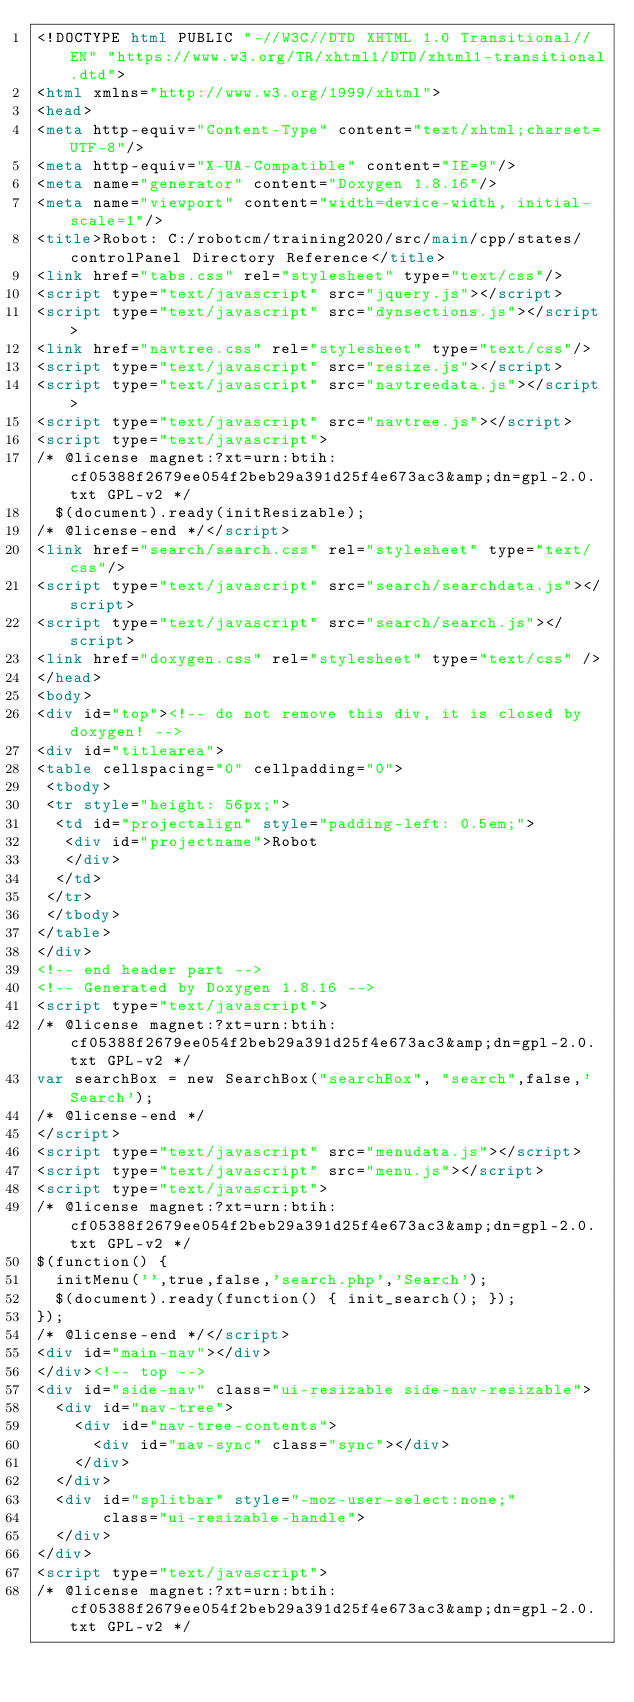Convert code to text. <code><loc_0><loc_0><loc_500><loc_500><_HTML_><!DOCTYPE html PUBLIC "-//W3C//DTD XHTML 1.0 Transitional//EN" "https://www.w3.org/TR/xhtml1/DTD/xhtml1-transitional.dtd">
<html xmlns="http://www.w3.org/1999/xhtml">
<head>
<meta http-equiv="Content-Type" content="text/xhtml;charset=UTF-8"/>
<meta http-equiv="X-UA-Compatible" content="IE=9"/>
<meta name="generator" content="Doxygen 1.8.16"/>
<meta name="viewport" content="width=device-width, initial-scale=1"/>
<title>Robot: C:/robotcm/training2020/src/main/cpp/states/controlPanel Directory Reference</title>
<link href="tabs.css" rel="stylesheet" type="text/css"/>
<script type="text/javascript" src="jquery.js"></script>
<script type="text/javascript" src="dynsections.js"></script>
<link href="navtree.css" rel="stylesheet" type="text/css"/>
<script type="text/javascript" src="resize.js"></script>
<script type="text/javascript" src="navtreedata.js"></script>
<script type="text/javascript" src="navtree.js"></script>
<script type="text/javascript">
/* @license magnet:?xt=urn:btih:cf05388f2679ee054f2beb29a391d25f4e673ac3&amp;dn=gpl-2.0.txt GPL-v2 */
  $(document).ready(initResizable);
/* @license-end */</script>
<link href="search/search.css" rel="stylesheet" type="text/css"/>
<script type="text/javascript" src="search/searchdata.js"></script>
<script type="text/javascript" src="search/search.js"></script>
<link href="doxygen.css" rel="stylesheet" type="text/css" />
</head>
<body>
<div id="top"><!-- do not remove this div, it is closed by doxygen! -->
<div id="titlearea">
<table cellspacing="0" cellpadding="0">
 <tbody>
 <tr style="height: 56px;">
  <td id="projectalign" style="padding-left: 0.5em;">
   <div id="projectname">Robot
   </div>
  </td>
 </tr>
 </tbody>
</table>
</div>
<!-- end header part -->
<!-- Generated by Doxygen 1.8.16 -->
<script type="text/javascript">
/* @license magnet:?xt=urn:btih:cf05388f2679ee054f2beb29a391d25f4e673ac3&amp;dn=gpl-2.0.txt GPL-v2 */
var searchBox = new SearchBox("searchBox", "search",false,'Search');
/* @license-end */
</script>
<script type="text/javascript" src="menudata.js"></script>
<script type="text/javascript" src="menu.js"></script>
<script type="text/javascript">
/* @license magnet:?xt=urn:btih:cf05388f2679ee054f2beb29a391d25f4e673ac3&amp;dn=gpl-2.0.txt GPL-v2 */
$(function() {
  initMenu('',true,false,'search.php','Search');
  $(document).ready(function() { init_search(); });
});
/* @license-end */</script>
<div id="main-nav"></div>
</div><!-- top -->
<div id="side-nav" class="ui-resizable side-nav-resizable">
  <div id="nav-tree">
    <div id="nav-tree-contents">
      <div id="nav-sync" class="sync"></div>
    </div>
  </div>
  <div id="splitbar" style="-moz-user-select:none;" 
       class="ui-resizable-handle">
  </div>
</div>
<script type="text/javascript">
/* @license magnet:?xt=urn:btih:cf05388f2679ee054f2beb29a391d25f4e673ac3&amp;dn=gpl-2.0.txt GPL-v2 */</code> 